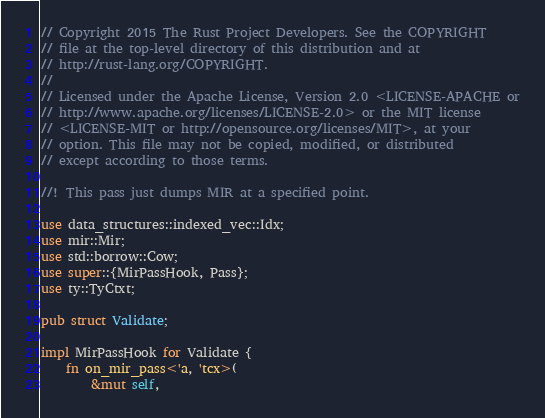Convert code to text. <code><loc_0><loc_0><loc_500><loc_500><_Rust_>// Copyright 2015 The Rust Project Developers. See the COPYRIGHT
// file at the top-level directory of this distribution and at
// http://rust-lang.org/COPYRIGHT.
//
// Licensed under the Apache License, Version 2.0 <LICENSE-APACHE or
// http://www.apache.org/licenses/LICENSE-2.0> or the MIT license
// <LICENSE-MIT or http://opensource.org/licenses/MIT>, at your
// option. This file may not be copied, modified, or distributed
// except according to those terms.

//! This pass just dumps MIR at a specified point.

use data_structures::indexed_vec::Idx;
use mir::Mir;
use std::borrow::Cow;
use super::{MirPassHook, Pass};
use ty::TyCtxt;

pub struct Validate;

impl MirPassHook for Validate {
    fn on_mir_pass<'a, 'tcx>(
        &mut self,</code> 